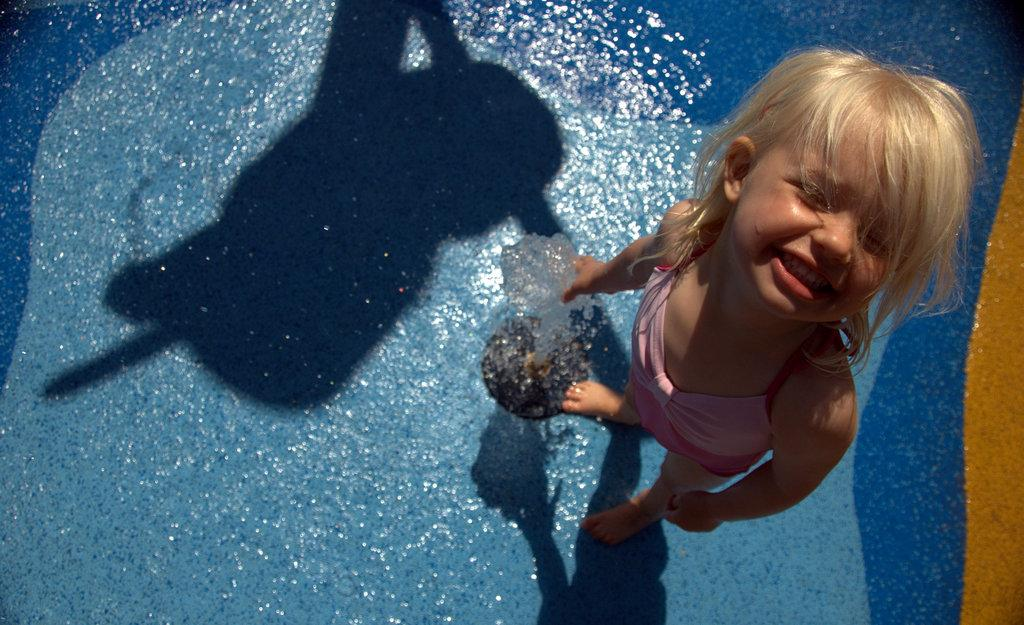Who is the main subject in the image? There is a girl in the image. What is the girl doing in the image? The girl is standing on a ground water fountain. What type of light is illuminating the girl in the image? There is no specific mention of a light source in the image, so it cannot be determined what type of light is illuminating the girl. 